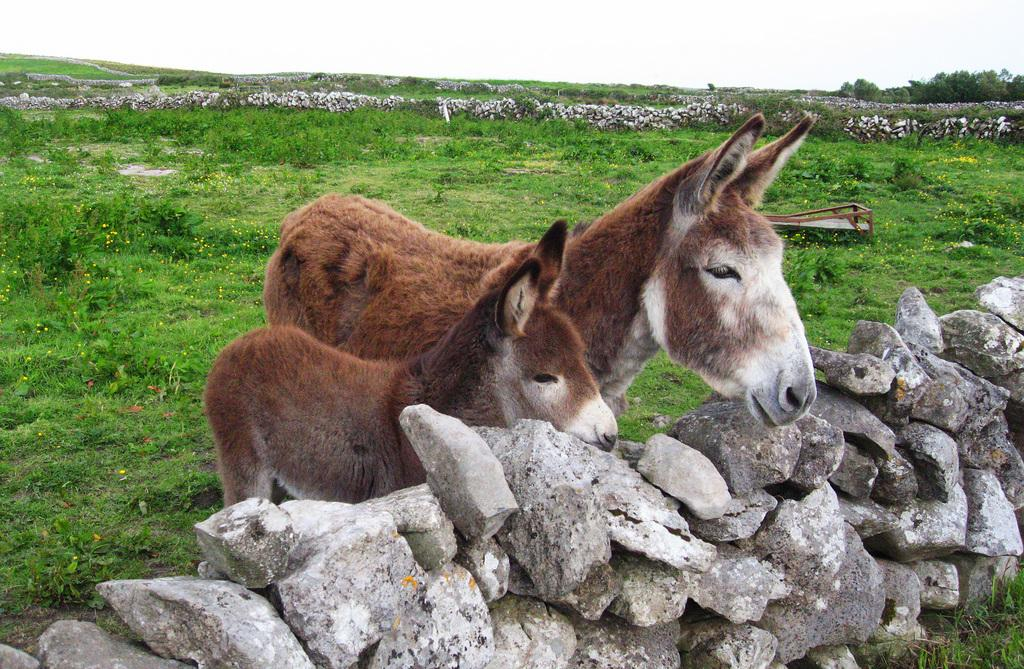What is located in the center of the image? There are animals in the center of the image. What is at the bottom of the image? There are rocks at the bottom of the image. What type of vegetation can be seen in the background of the image? There is grass and trees in the background of the image. What is visible in the background of the image besides vegetation? The sky is visible in the background of the image. What type of scarf is draped over the trees in the image? There is no scarf present in the image; it features animals, rocks, grass, trees, and the sky. How many pickles are visible on the rocks in the image? There are no pickles present in the image; it features animals, rocks, grass, trees, and the sky. 